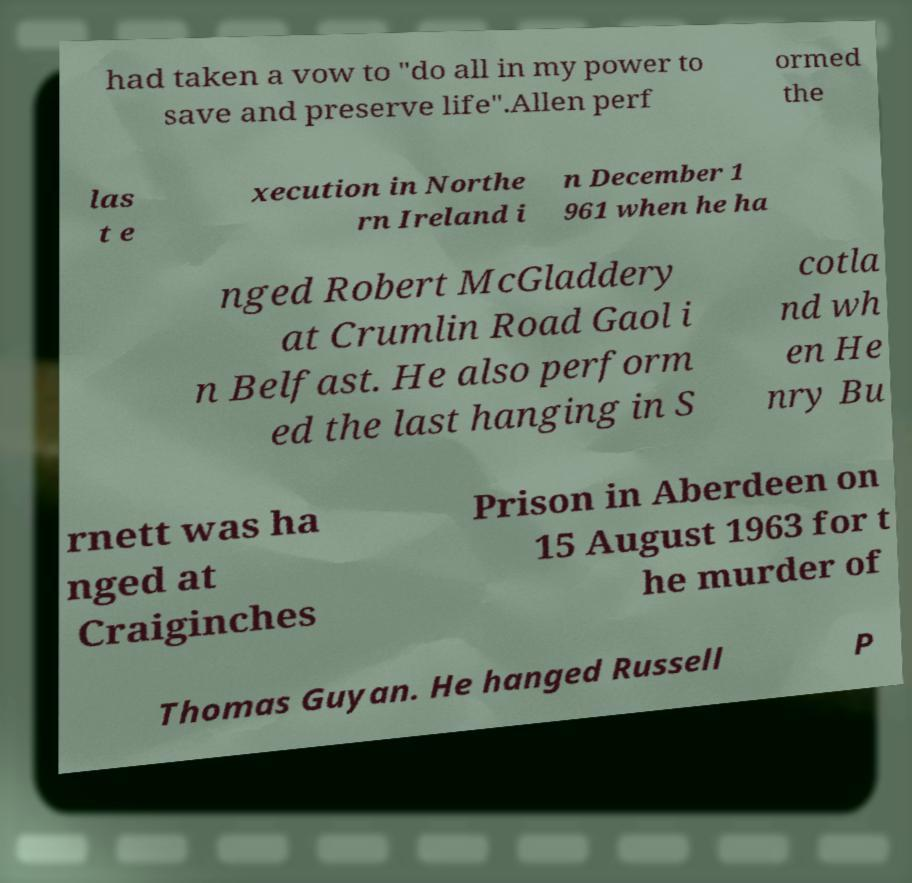There's text embedded in this image that I need extracted. Can you transcribe it verbatim? had taken a vow to "do all in my power to save and preserve life".Allen perf ormed the las t e xecution in Northe rn Ireland i n December 1 961 when he ha nged Robert McGladdery at Crumlin Road Gaol i n Belfast. He also perform ed the last hanging in S cotla nd wh en He nry Bu rnett was ha nged at Craiginches Prison in Aberdeen on 15 August 1963 for t he murder of Thomas Guyan. He hanged Russell P 